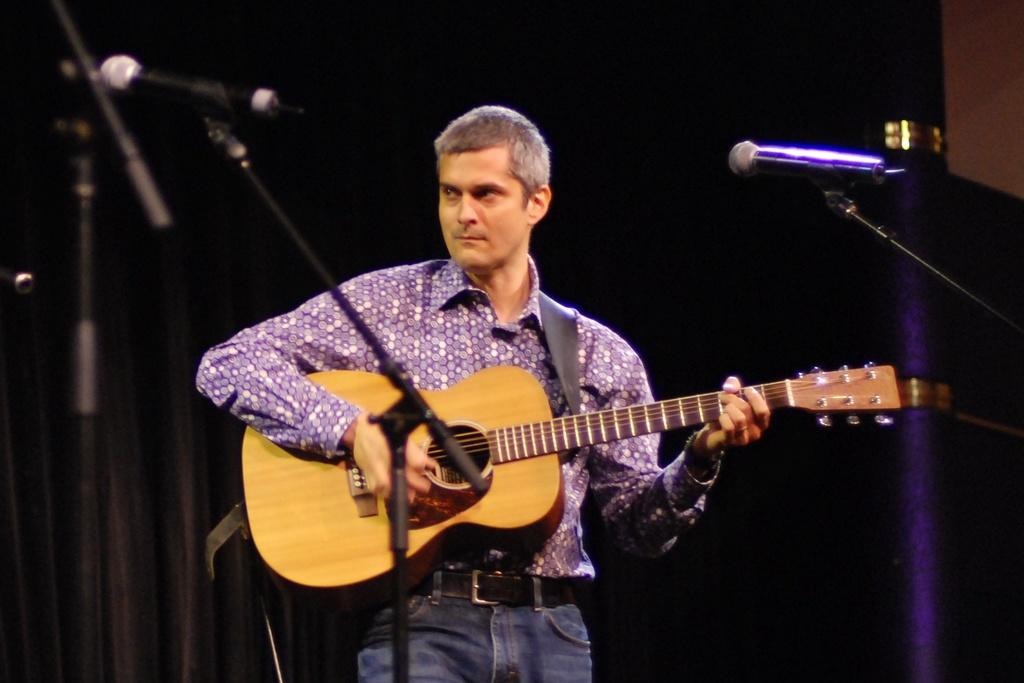Who is the main subject in the image? There is a man in the image. What is the man doing in the image? The man is playing a guitar. What objects are present in the image that might be related to the man's activity? There are microphones in the image. What type of popcorn is being served to the visitor in the image? There is no popcorn or visitor present in the image; it features a man playing a guitar and microphones. 